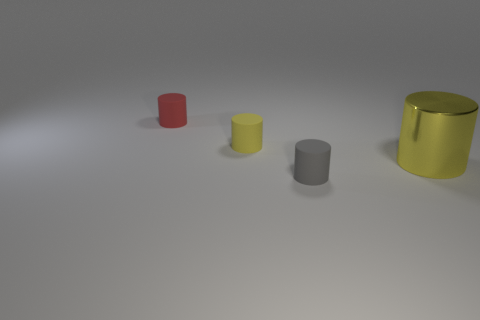Is the number of big yellow things greater than the number of large red matte cubes?
Your answer should be compact. Yes. Does the tiny object that is in front of the large yellow shiny cylinder have the same material as the red cylinder?
Provide a succinct answer. Yes. Is the number of tiny matte things less than the number of big brown matte blocks?
Provide a succinct answer. No. There is a yellow cylinder that is on the left side of the small matte object that is in front of the large yellow cylinder; are there any metallic objects to the right of it?
Provide a short and direct response. Yes. There is a rubber object that is in front of the big yellow shiny object; is it the same shape as the big object?
Your answer should be very brief. Yes. Are there more small red rubber cylinders that are on the left side of the tiny yellow thing than small gray objects?
Make the answer very short. No. Is the color of the tiny object in front of the yellow matte thing the same as the big shiny object?
Keep it short and to the point. No. Is there any other thing that has the same color as the metal object?
Make the answer very short. Yes. The thing in front of the object that is right of the matte cylinder that is in front of the big cylinder is what color?
Your response must be concise. Gray. Do the gray cylinder and the yellow shiny cylinder have the same size?
Your answer should be very brief. No. 